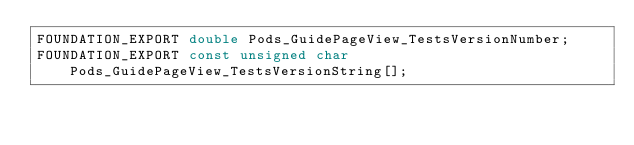<code> <loc_0><loc_0><loc_500><loc_500><_C_>FOUNDATION_EXPORT double Pods_GuidePageView_TestsVersionNumber;
FOUNDATION_EXPORT const unsigned char Pods_GuidePageView_TestsVersionString[];

</code> 